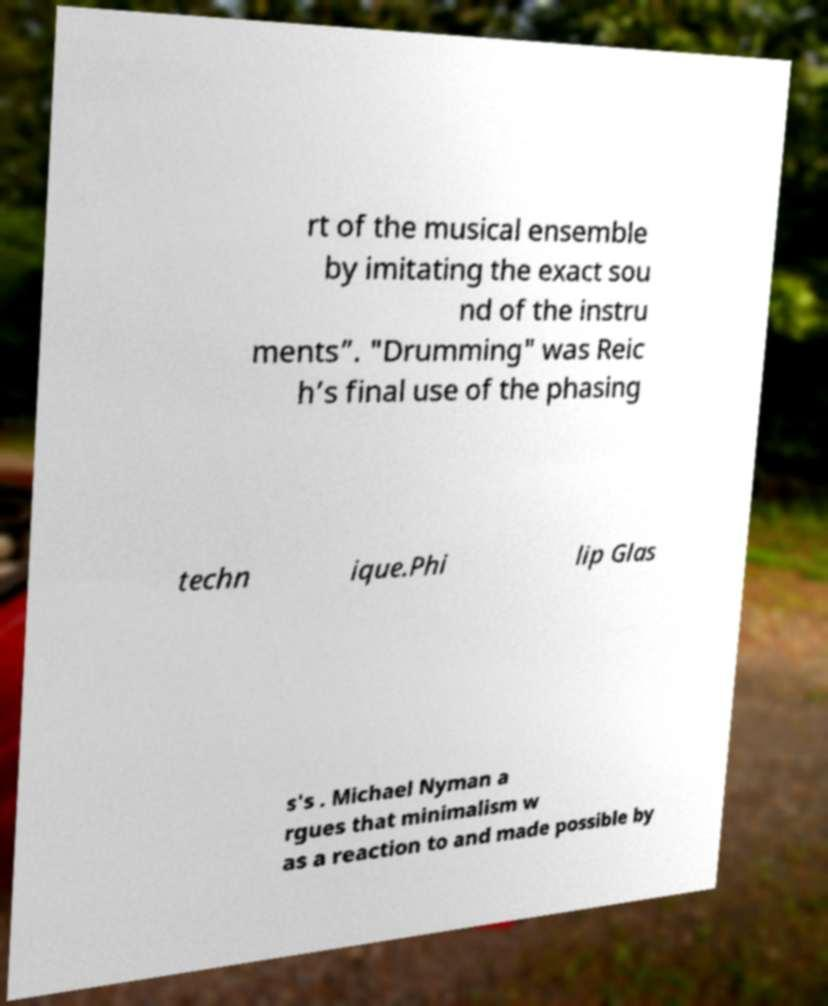For documentation purposes, I need the text within this image transcribed. Could you provide that? rt of the musical ensemble by imitating the exact sou nd of the instru ments”. "Drumming" was Reic h’s final use of the phasing techn ique.Phi lip Glas s's . Michael Nyman a rgues that minimalism w as a reaction to and made possible by 